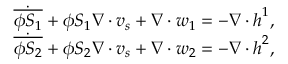<formula> <loc_0><loc_0><loc_500><loc_500>\begin{array} { r l } & { \dot { \overline { { \phi S _ { 1 } } } } + \phi S _ { 1 } \nabla \cdot v _ { s } + \nabla \cdot w _ { 1 } = - \nabla \cdot h ^ { 1 } , } \\ & { \dot { \overline { { \phi S _ { 2 } } } } + \phi S _ { 2 } \nabla \cdot v _ { s } + \nabla \cdot w _ { 2 } = - \nabla \cdot h ^ { 2 } , } \end{array}</formula> 